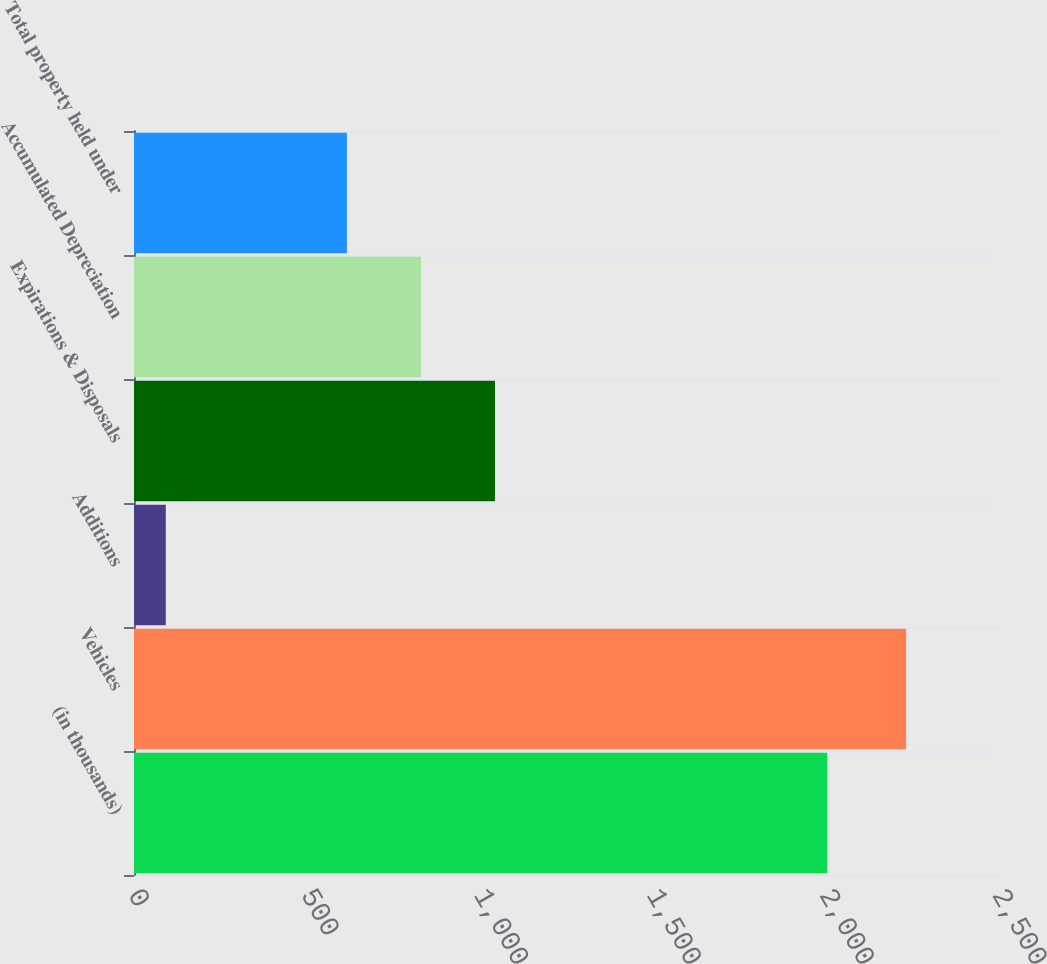<chart> <loc_0><loc_0><loc_500><loc_500><bar_chart><fcel>(in thousands)<fcel>Vehicles<fcel>Additions<fcel>Expirations & Disposals<fcel>Accumulated Depreciation<fcel>Total property held under<nl><fcel>2006<fcel>2234<fcel>92<fcel>1044.4<fcel>830.2<fcel>616<nl></chart> 